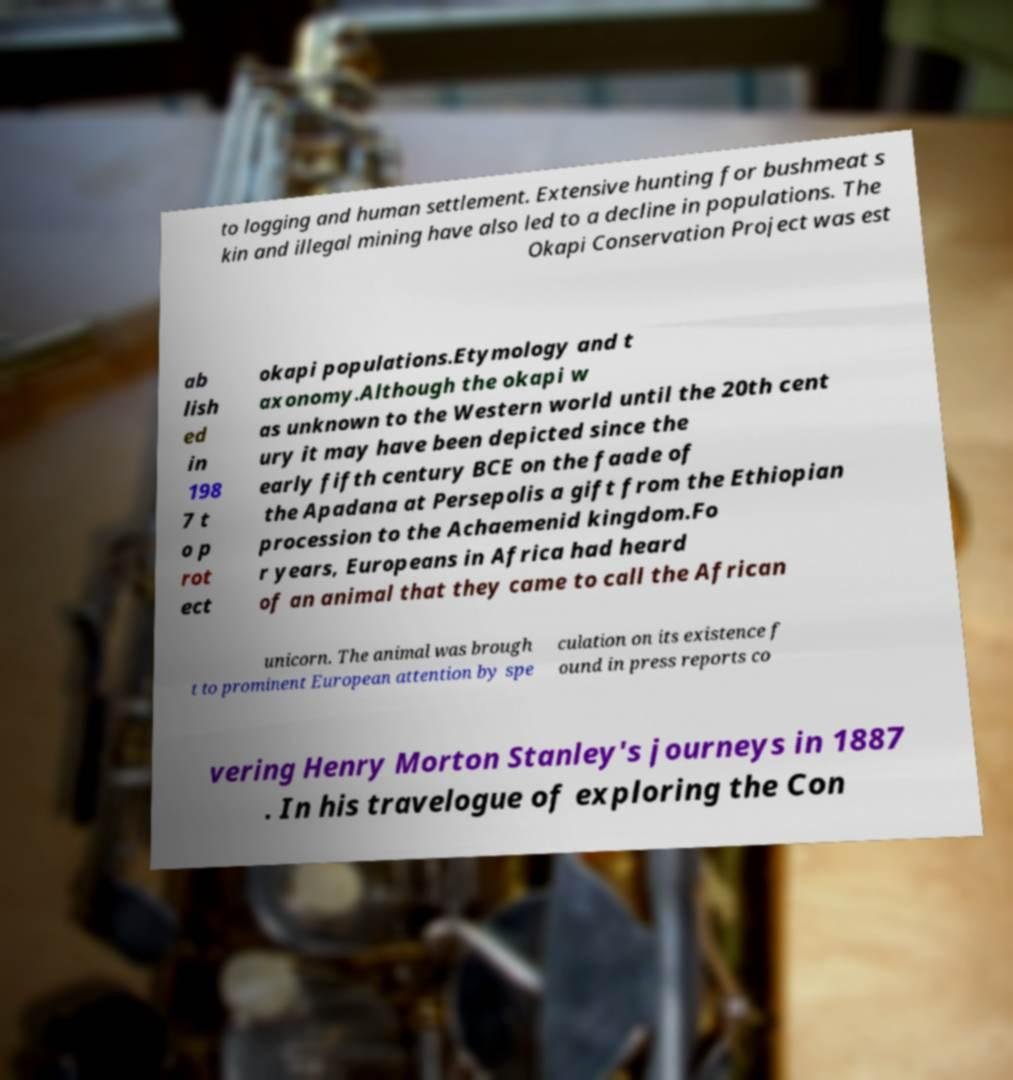There's text embedded in this image that I need extracted. Can you transcribe it verbatim? to logging and human settlement. Extensive hunting for bushmeat s kin and illegal mining have also led to a decline in populations. The Okapi Conservation Project was est ab lish ed in 198 7 t o p rot ect okapi populations.Etymology and t axonomy.Although the okapi w as unknown to the Western world until the 20th cent ury it may have been depicted since the early fifth century BCE on the faade of the Apadana at Persepolis a gift from the Ethiopian procession to the Achaemenid kingdom.Fo r years, Europeans in Africa had heard of an animal that they came to call the African unicorn. The animal was brough t to prominent European attention by spe culation on its existence f ound in press reports co vering Henry Morton Stanley's journeys in 1887 . In his travelogue of exploring the Con 